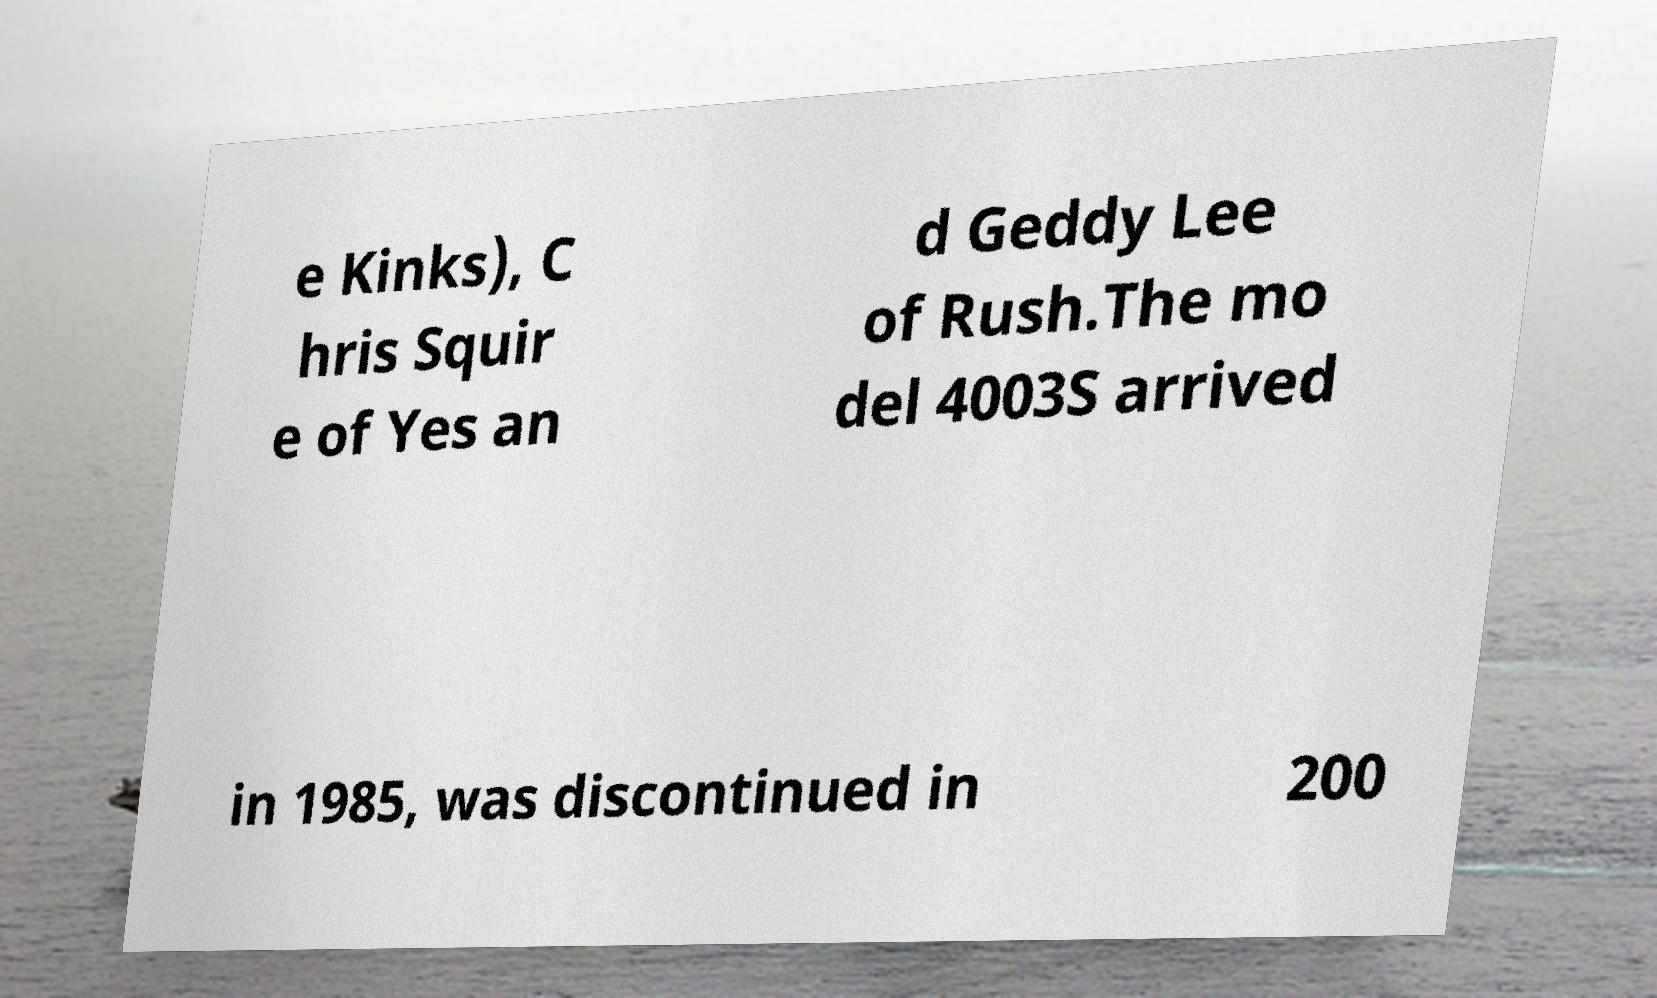Could you assist in decoding the text presented in this image and type it out clearly? e Kinks), C hris Squir e of Yes an d Geddy Lee of Rush.The mo del 4003S arrived in 1985, was discontinued in 200 